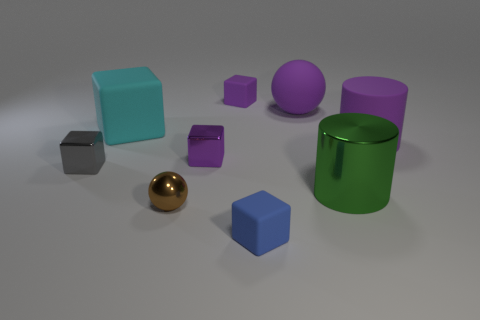What is the color of the thing that is left of the blue object and behind the big cyan matte cube?
Provide a succinct answer. Purple. The brown shiny ball has what size?
Offer a terse response. Small. There is a large rubber object to the right of the big green metal object; is its color the same as the big shiny thing?
Give a very brief answer. No. Is the number of brown spheres left of the brown thing greater than the number of blocks to the right of the big shiny thing?
Ensure brevity in your answer.  No. Is the number of tiny red cylinders greater than the number of tiny gray things?
Your answer should be compact. No. There is a purple object that is in front of the large ball and on the left side of the matte cylinder; how big is it?
Your answer should be very brief. Small. There is a small purple matte object; what shape is it?
Offer a very short reply. Cube. Are there any other things that have the same size as the blue block?
Give a very brief answer. Yes. Are there more tiny objects in front of the gray object than large green shiny cylinders?
Your answer should be compact. Yes. What shape is the purple object on the left side of the tiny rubber cube that is behind the big thing to the left of the small blue object?
Provide a succinct answer. Cube. 